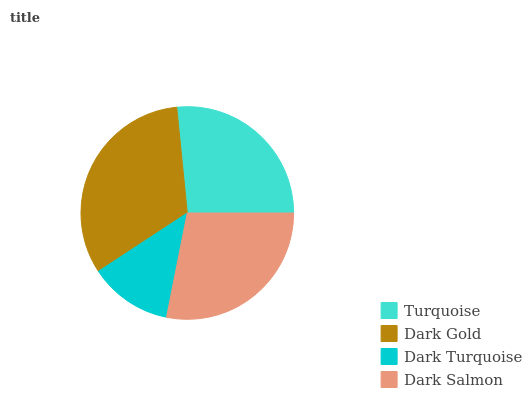Is Dark Turquoise the minimum?
Answer yes or no. Yes. Is Dark Gold the maximum?
Answer yes or no. Yes. Is Dark Gold the minimum?
Answer yes or no. No. Is Dark Turquoise the maximum?
Answer yes or no. No. Is Dark Gold greater than Dark Turquoise?
Answer yes or no. Yes. Is Dark Turquoise less than Dark Gold?
Answer yes or no. Yes. Is Dark Turquoise greater than Dark Gold?
Answer yes or no. No. Is Dark Gold less than Dark Turquoise?
Answer yes or no. No. Is Dark Salmon the high median?
Answer yes or no. Yes. Is Turquoise the low median?
Answer yes or no. Yes. Is Dark Turquoise the high median?
Answer yes or no. No. Is Dark Gold the low median?
Answer yes or no. No. 